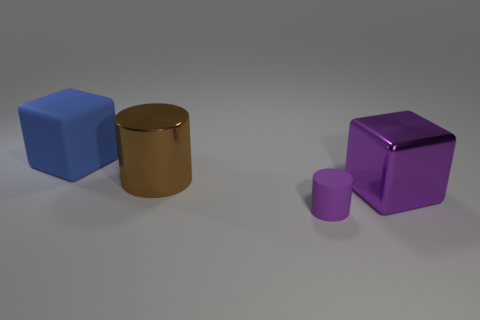What is the large block to the right of the blue matte cube made of?
Provide a short and direct response. Metal. Is there anything else that is the same material as the large purple object?
Make the answer very short. Yes. Are there more big purple shiny objects behind the large blue rubber cube than blue things?
Ensure brevity in your answer.  No. Is there a metal cylinder in front of the big object right of the big shiny thing that is to the left of the purple metal thing?
Make the answer very short. No. There is a purple block; are there any blue things behind it?
Give a very brief answer. Yes. What number of big metallic blocks are the same color as the small thing?
Your response must be concise. 1. What size is the thing that is the same material as the brown cylinder?
Your response must be concise. Large. There is a object in front of the big object right of the large cylinder on the right side of the large matte block; how big is it?
Provide a succinct answer. Small. There is a blue thing behind the purple block; what is its size?
Ensure brevity in your answer.  Large. How many red things are either metal cylinders or small matte things?
Provide a succinct answer. 0. 